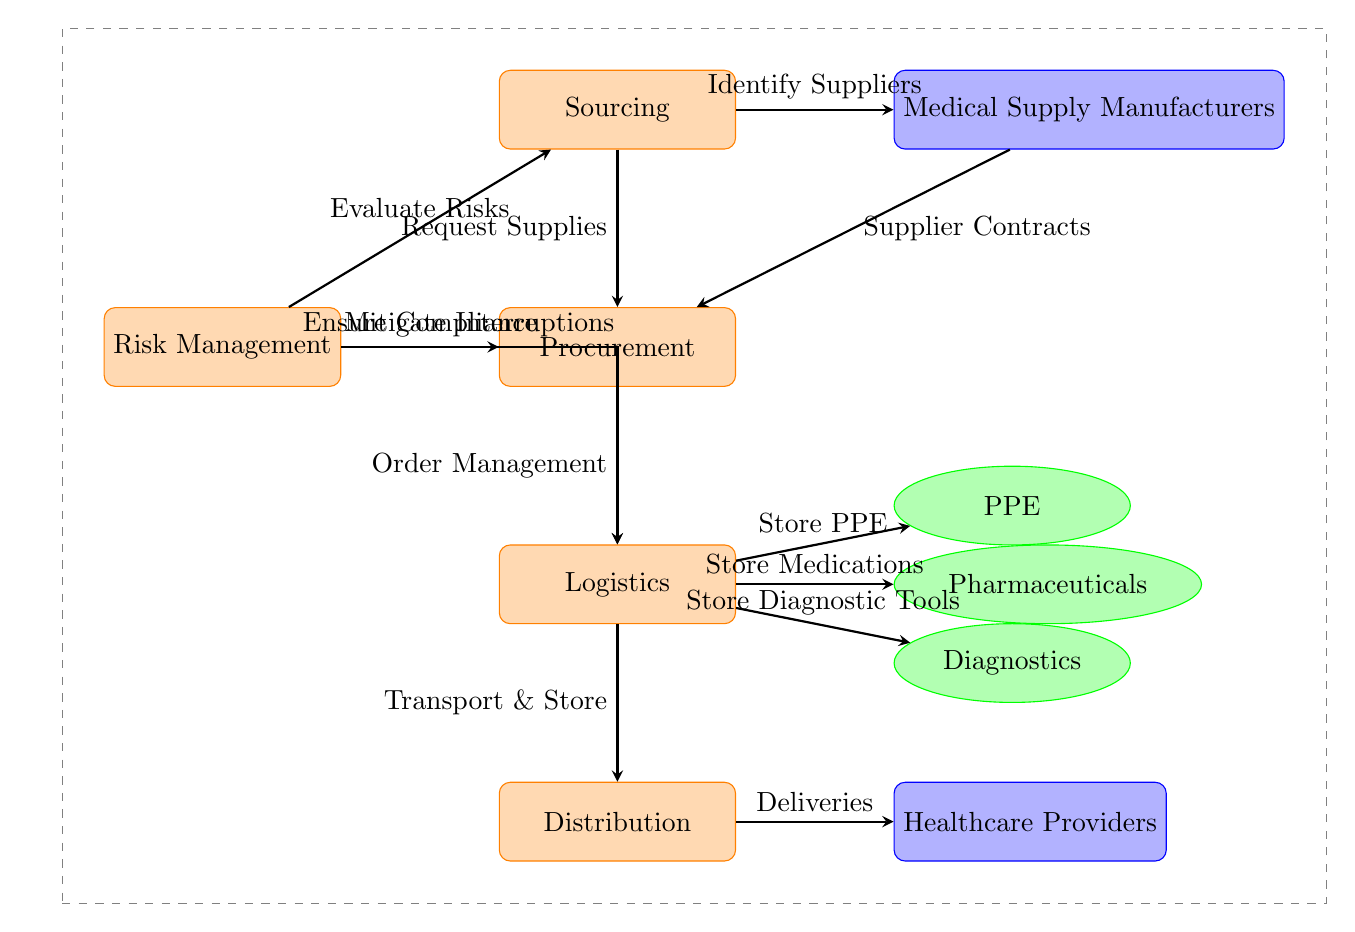What is the first process in the diagram? The diagram starts with a process labeled "Sourcing," located at the top of the flow, which initiates the sequence of steps.
Answer: Sourcing How many supplier categories are present in the diagram? There are two supplier categories in the diagram: "Medical Supply Manufacturers" and "Healthcare Providers." Therefore, the count of supplier categories is two.
Answer: Two What action follows procurement in the process flow? After procurement, the next action is "Logistics," which is the next node directly below it, indicating the flow from one process to another.
Answer: Logistics What is the purpose of the Risk Management process in the diagram? The "Risk Management" process is critical as it evaluates risks, ensures compliance, and mitigates interruptions, which is indicated by its arrows leading to various other nodes in the diagram.
Answer: Evaluate Risks, Ensure Compliance, Mitigate Interruptions Which products are stored during the logistics process? The logistics process involves storing three types of products: "PPE" (Personal Protective Equipment), "Medications," and "Diagnostic Tools." These are displayed as nodes connected to the logistics process.
Answer: PPE, Medications, Diagnostic Tools What are the two immediate follow-up processes that suppliers relate to in the diagram? The suppliers relate to two immediate follow-up processes: they are connected to procurement through "Supplier Contracts" and sourcing through "Identify Suppliers," indicating their role in those processes.
Answer: Supplier Contracts, Identify Suppliers How does the risk management process affect the logistics? The risk management process mitigates interruptions to logistics, as shown by the arrow indicating that it directly influences this stage, ensuring smoother operations.
Answer: Mitigate Interruptions What does the distribution process lead to in the diagram? The distribution process leads to "Healthcare Providers," indicating the final stage in the supply chain where medical supplies are delivered to the end users.
Answer: Healthcare Providers 